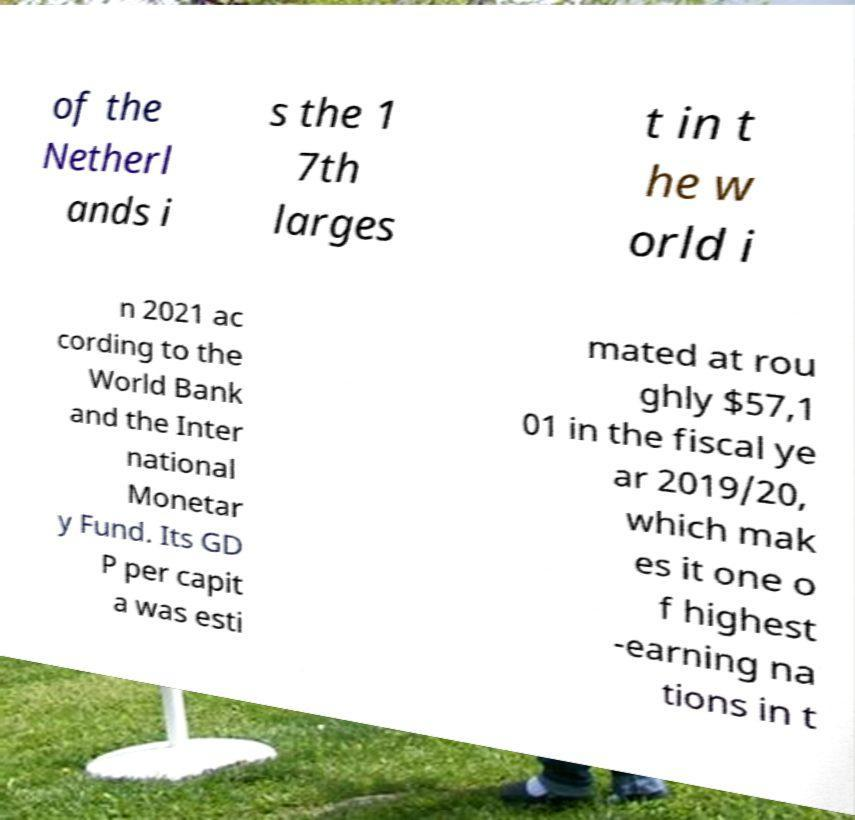Can you accurately transcribe the text from the provided image for me? of the Netherl ands i s the 1 7th larges t in t he w orld i n 2021 ac cording to the World Bank and the Inter national Monetar y Fund. Its GD P per capit a was esti mated at rou ghly $57,1 01 in the fiscal ye ar 2019/20, which mak es it one o f highest -earning na tions in t 